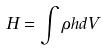<formula> <loc_0><loc_0><loc_500><loc_500>H = \int \rho h d V</formula> 